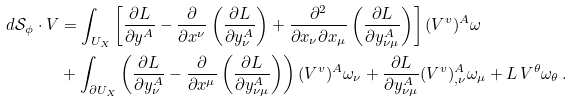Convert formula to latex. <formula><loc_0><loc_0><loc_500><loc_500>d \mathcal { S } _ { \phi } \cdot V & = \int _ { U _ { X } } \left [ \frac { \partial L } { \partial y ^ { A } } - \frac { \partial } { \partial x ^ { \nu } } \left ( \frac { \partial L } { \partial y ^ { A } _ { \nu } } \right ) + \frac { \partial ^ { 2 } } { \partial x _ { \nu } \partial x _ { \mu } } \left ( \frac { \partial L } { \partial y ^ { A } _ { \nu \mu } } \right ) \right ] ( V ^ { v } ) ^ { A } \omega \\ & + \int _ { \partial U _ { X } } \left ( \frac { \partial L } { \partial y ^ { A } _ { \nu } } - \frac { \partial } { \partial x ^ { \mu } } \left ( \frac { \partial L } { \partial y ^ { A } _ { \nu \mu } } \right ) \right ) ( V ^ { v } ) ^ { A } \omega _ { \nu } + \frac { \partial L } { \partial y ^ { A } _ { \nu \mu } } ( V ^ { v } ) ^ { A } _ { , \nu } \omega _ { \mu } + L \, V ^ { \theta } \omega _ { \theta } \, .</formula> 